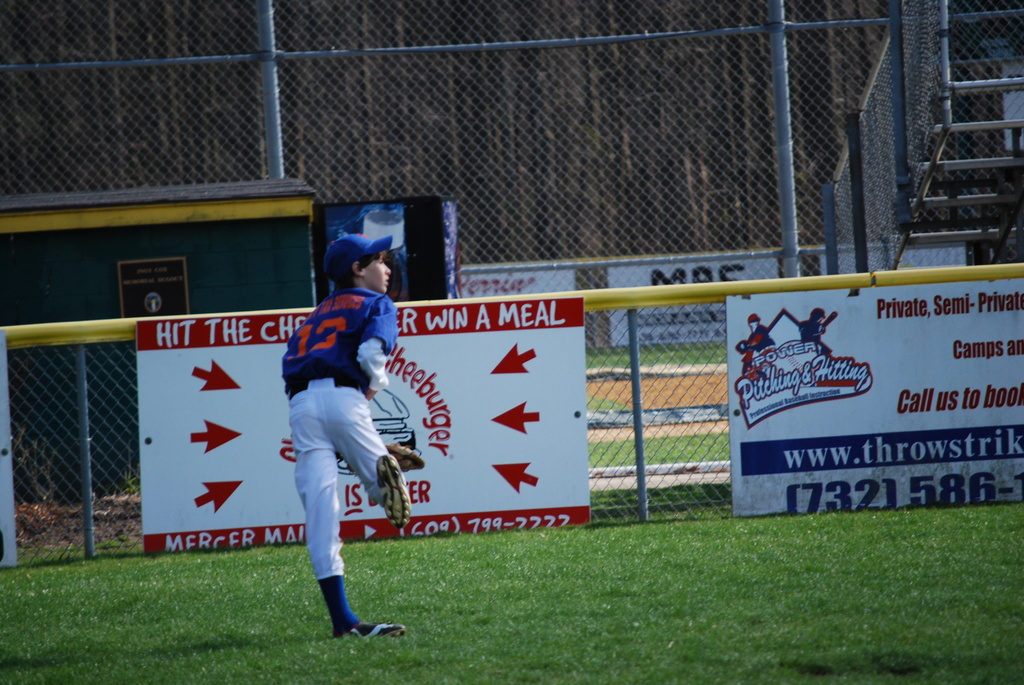Why might it be beneficial for local businesses to advertise at community sports events? Local businesses benefit from advertising at community sports events as it helps establish their presence within the community, enhances their local reputation, and can lead to increased patronage. Sports events often draw family-oriented and community-focused crowds, making them ideal audiences for local marketing efforts. 